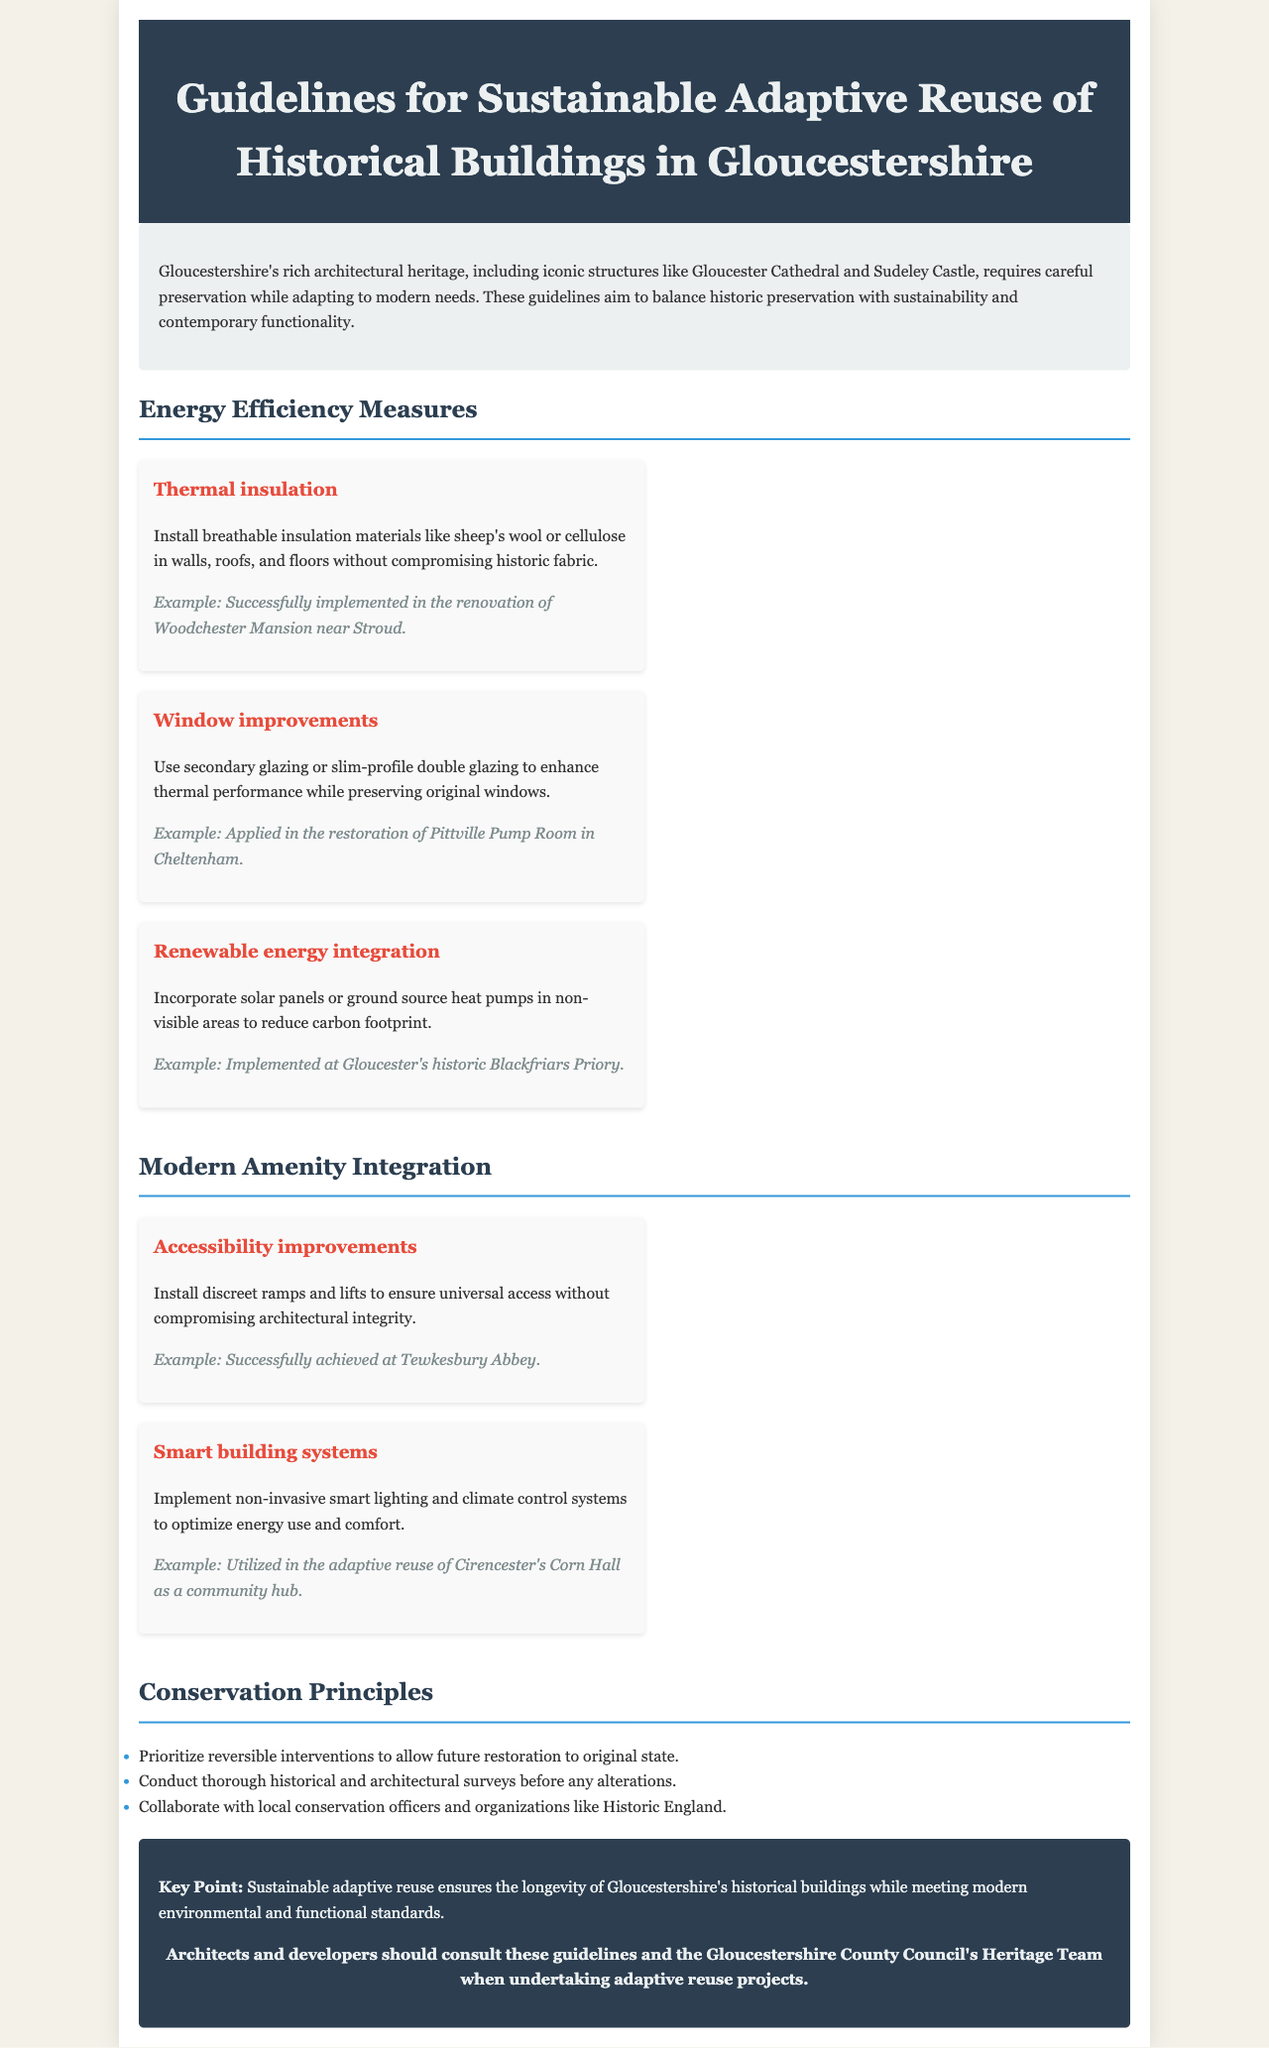what is the title of the document? The title is stated at the beginning of the document and outlines the guidelines it covers.
Answer: Guidelines for Sustainable Adaptive Reuse of Historical Buildings in Gloucestershire what is one example of renewable energy integration mentioned? The document provides an example of a location where renewable energy measures have been successfully integrated.
Answer: Gloucester's historic Blackfriars Priory which building's renovation utilized sustainable thermal insulation? The document states a specific historical building where thermal insulation was successfully implemented.
Answer: Woodchester Mansion how many energy efficiency measures are listed? The document lists specific measures for energy efficiency in buildings.
Answer: Three which structure successfully achieved accessibility improvements? The document provides an example of a building that has incorporated accessibility measures.
Answer: Tewkesbury Abbey what is one principle of conservation mentioned? The document outlines several principles that guide the conservation process.
Answer: Prioritize reversible interventions what type of building systems are suggested for modern amenity integration? The document specifies the kind of technology that can be integrated into historical buildings without compromising their integrity.
Answer: Smart building systems who should be consulted for adaptive reuse projects? The document advises consulting a specific team for guidance on these types of projects.
Answer: Gloucestershire County Council's Heritage Team what color is used for the header background of the document? The header's background color is mentioned and contributes to the visual design.
Answer: Dark blue 